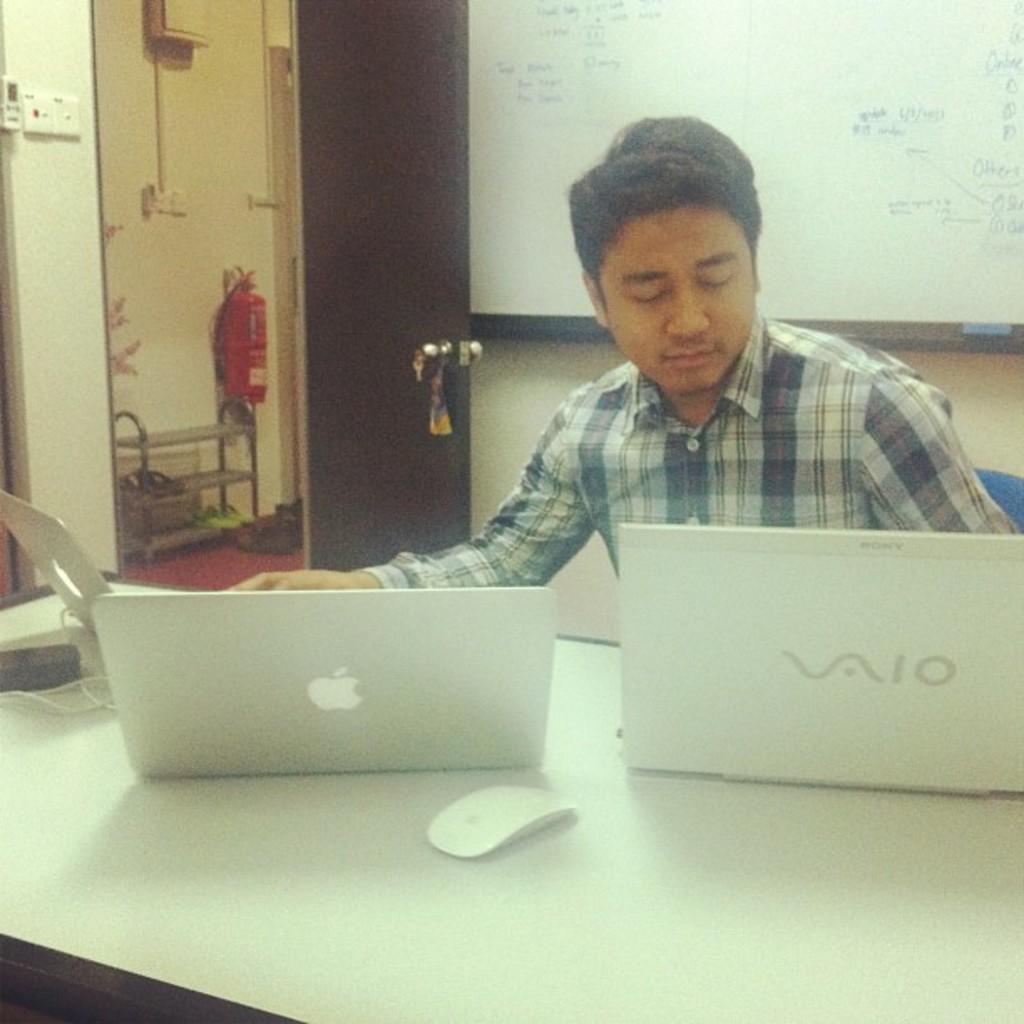Describe this image in one or two sentences. There is a room. He is sitting in a chair. He is looking into his laptop. We can see in the background there is a door,projector,board and fire extinguisher. There is a table. there is a laptop on a table. 